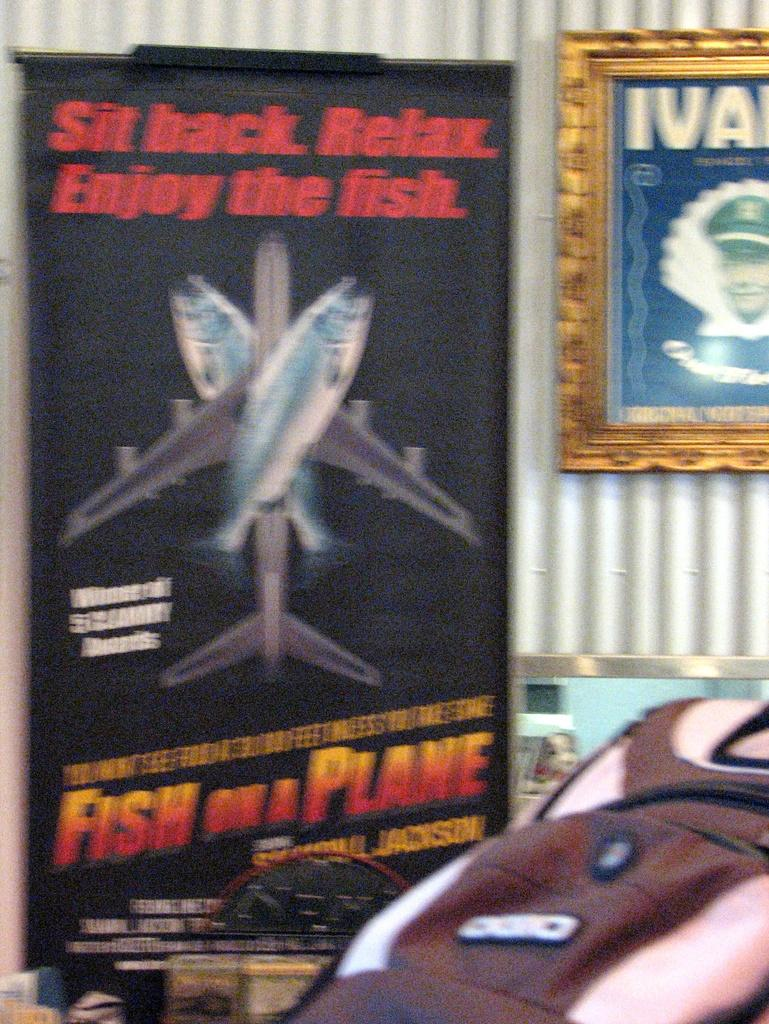<image>
Summarize the visual content of the image. A poster in front of striped wallpaper for a movie called Fish On A Plane featuring Samuel Jackson. 